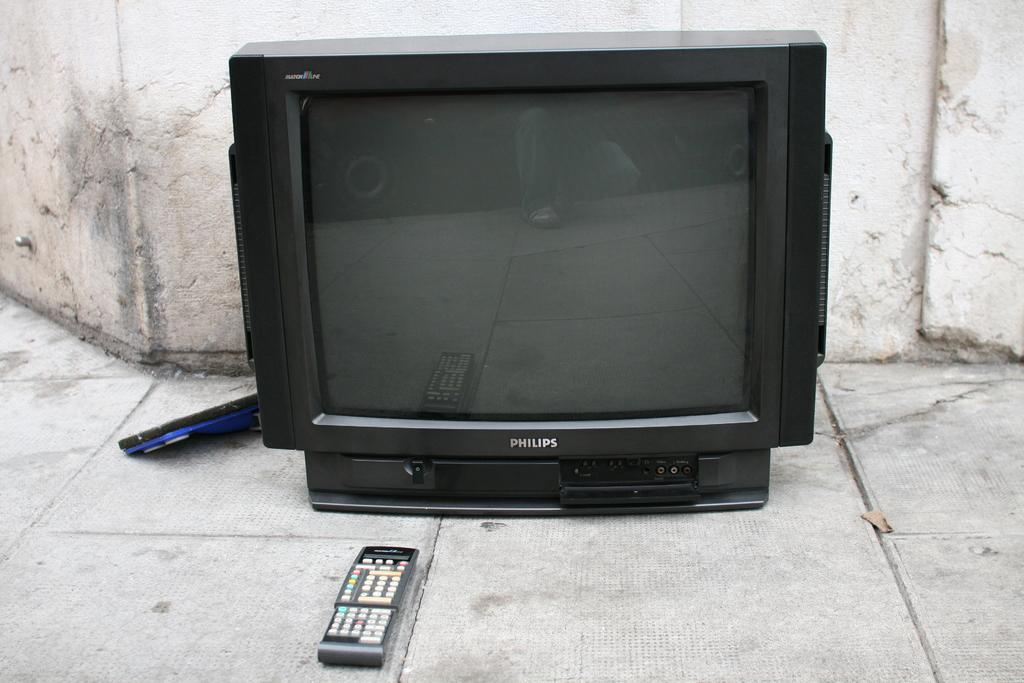Provide a one-sentence caption for the provided image. A MATCHLINE PHILIPS TV is on the ground with the remote in front of it. 